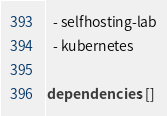Convert code to text. <code><loc_0><loc_0><loc_500><loc_500><_YAML_>  - selfhosting-lab
  - kubernetes

dependencies: []

</code> 